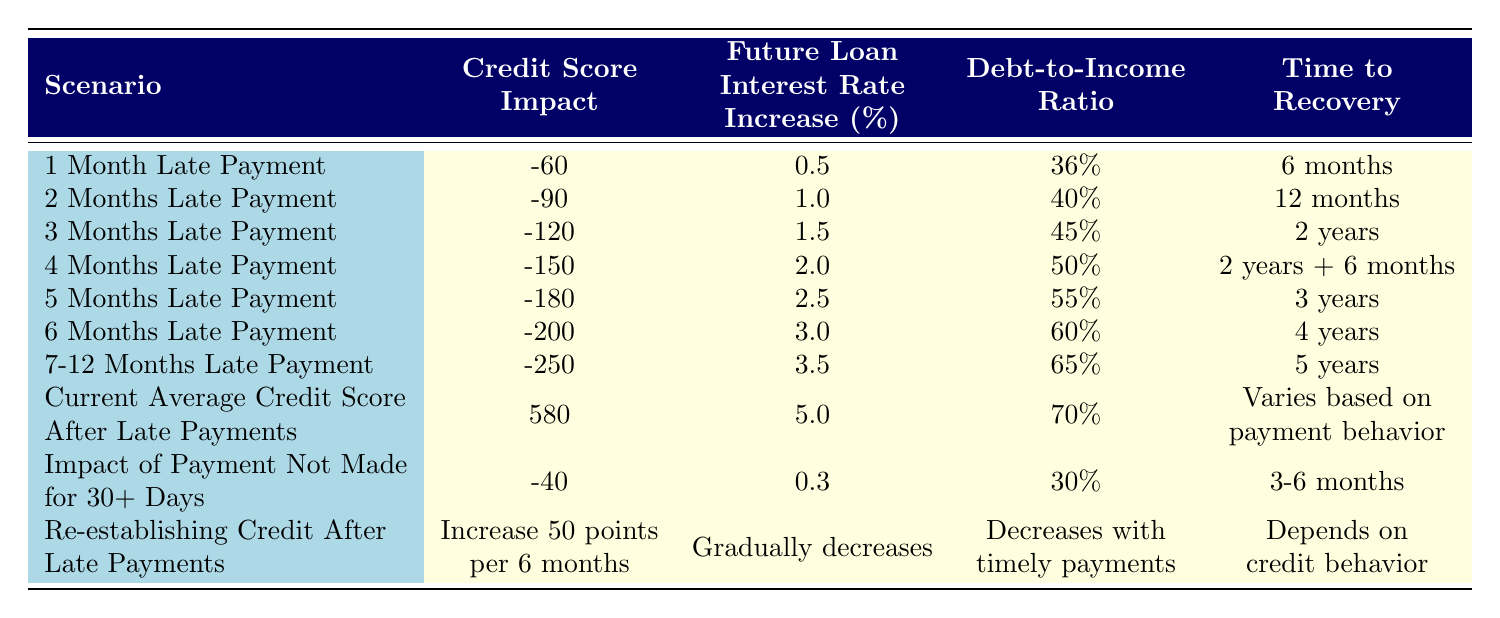What is the credit score impact of being 3 months late on a payment? From the table, the row for "3 Months Late Payment" indicates a credit score impact of -120.
Answer: -120 How long will it take to recover from a 4 months late payment? The "Time to Recovery" for "4 Months Late Payment" shows 2 years + 6 months.
Answer: 2 years + 6 months If someone is 6 months late on a payment, what will their debt-to-income ratio be? In the row for "6 Months Late Payment," the debt-to-income ratio is listed as 60%.
Answer: 60% Is it true that the future loan interest rate increases with longer late payment durations? Yes, examining the future loan interest rate increases across the scenarios, it rises with the duration of late payments.
Answer: Yes What is the average credit score impact for late payments from 1 to 6 months? The average credit score impact is calculated as follows: (-60 + -90 + -120 + -150 + -180 + -200) / 6 = -120.
Answer: -120 How much does the credit score increase per 6 months when re-establishing credit after late payments? The "Re-establishing Credit After Late Payments" row states an increase of 50 points per 6 months.
Answer: 50 points After 7-12 months late on a payment, how much will the future loan interest rate increase? Looking at the "7-12 Months Late Payment" scenario, the future loan interest rate increase is 3.5%.
Answer: 3.5% What is the relationship between the number of months late and the debt-to-income ratio? The debt-to-income ratio increases with the number of months late, ranging from 36% at 1 month to 65% at 7-12 months.
Answer: It increases How long does it take to recover after missing a payment for more than 30 days? The "Impact of Payment Not Made for 30+ Days" row states the time to recovery is 3-6 months.
Answer: 3-6 months If a person has made a late payment for 5 months, what is the future loan interest rate increase projected to be? The "5 Months Late Payment" row indicates a future loan interest rate increase of 2.5%.
Answer: 2.5% 